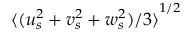Convert formula to latex. <formula><loc_0><loc_0><loc_500><loc_500>{ \langle ( u _ { s } ^ { 2 } + v _ { s } ^ { 2 } + w _ { s } ^ { 2 } ) / 3 \rangle } ^ { 1 / 2 }</formula> 